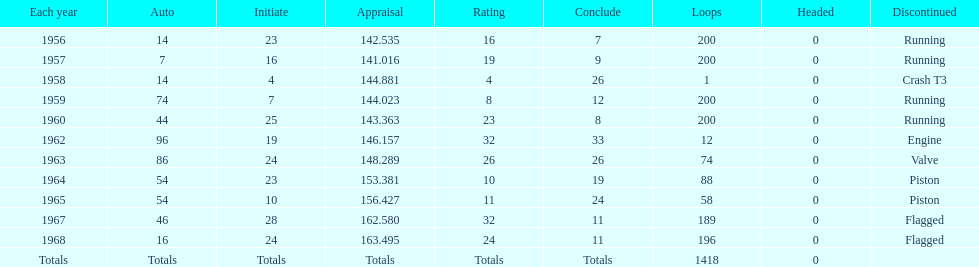Which year is the last qual on the chart 1968. 